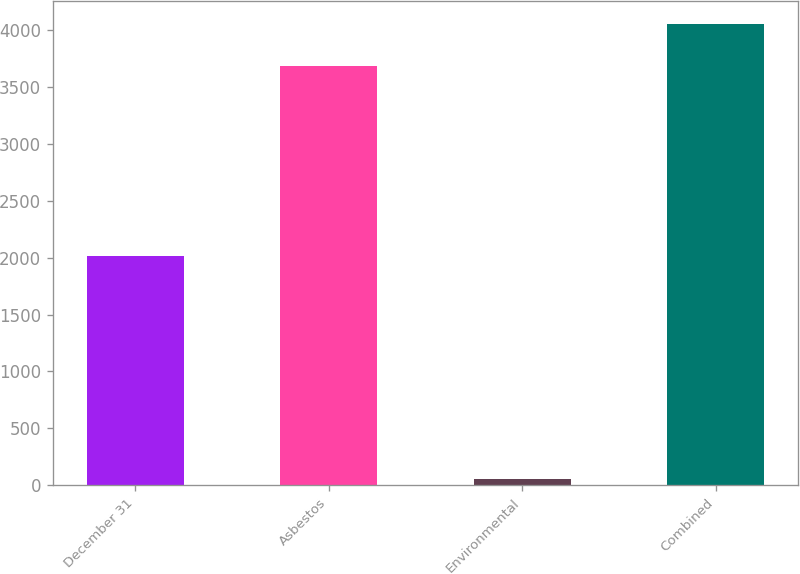Convert chart to OTSL. <chart><loc_0><loc_0><loc_500><loc_500><bar_chart><fcel>December 31<fcel>Asbestos<fcel>Environmental<fcel>Combined<nl><fcel>2011<fcel>3685<fcel>57<fcel>4053.5<nl></chart> 